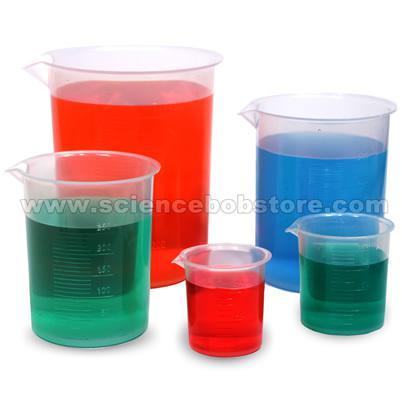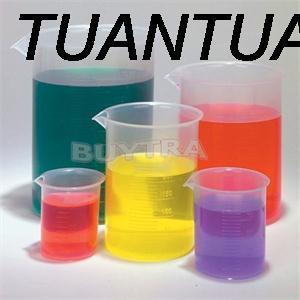The first image is the image on the left, the second image is the image on the right. Assess this claim about the two images: "The left and right image contains the same number of filled beckers.". Correct or not? Answer yes or no. Yes. 